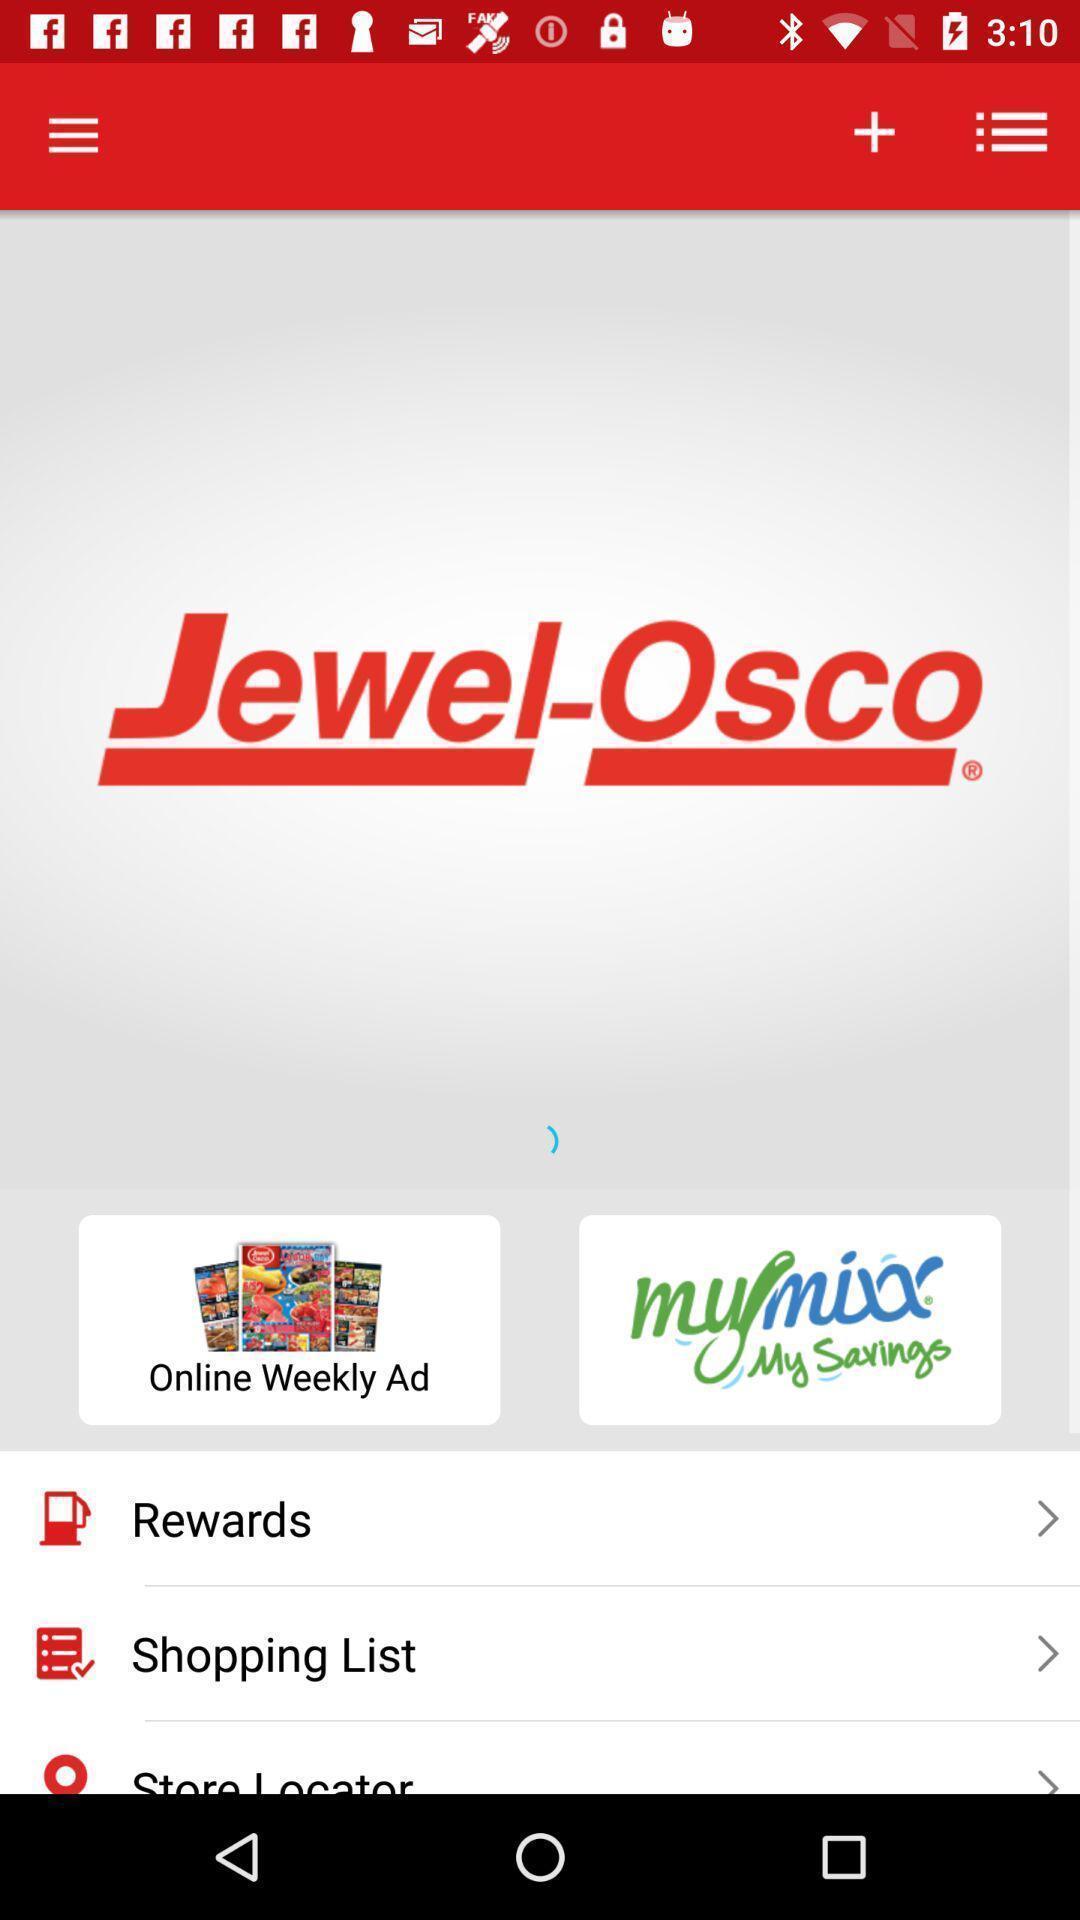Summarize the information in this screenshot. Welcome page of a shopping app. 